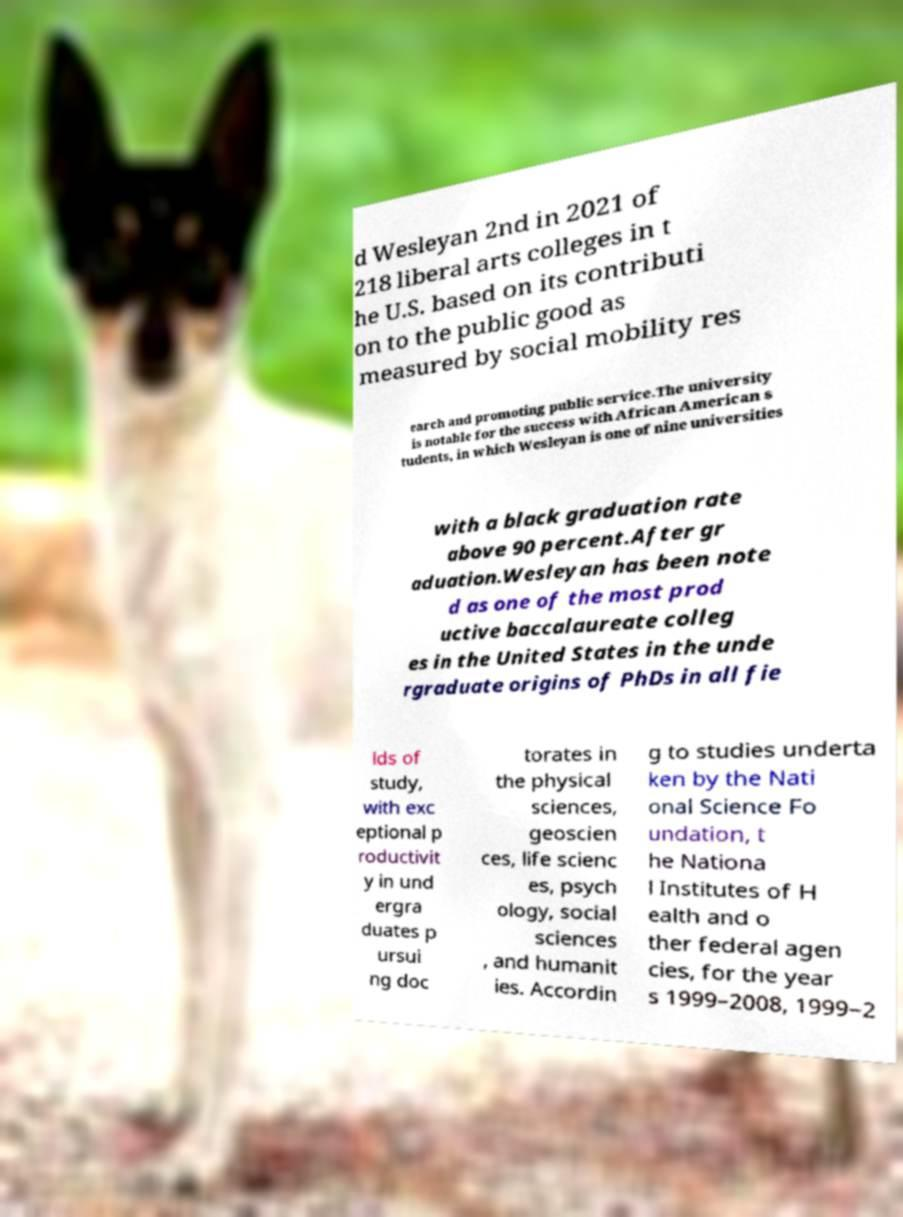Could you assist in decoding the text presented in this image and type it out clearly? d Wesleyan 2nd in 2021 of 218 liberal arts colleges in t he U.S. based on its contributi on to the public good as measured by social mobility res earch and promoting public service.The university is notable for the success with African American s tudents, in which Wesleyan is one of nine universities with a black graduation rate above 90 percent.After gr aduation.Wesleyan has been note d as one of the most prod uctive baccalaureate colleg es in the United States in the unde rgraduate origins of PhDs in all fie lds of study, with exc eptional p roductivit y in und ergra duates p ursui ng doc torates in the physical sciences, geoscien ces, life scienc es, psych ology, social sciences , and humanit ies. Accordin g to studies underta ken by the Nati onal Science Fo undation, t he Nationa l Institutes of H ealth and o ther federal agen cies, for the year s 1999–2008, 1999–2 